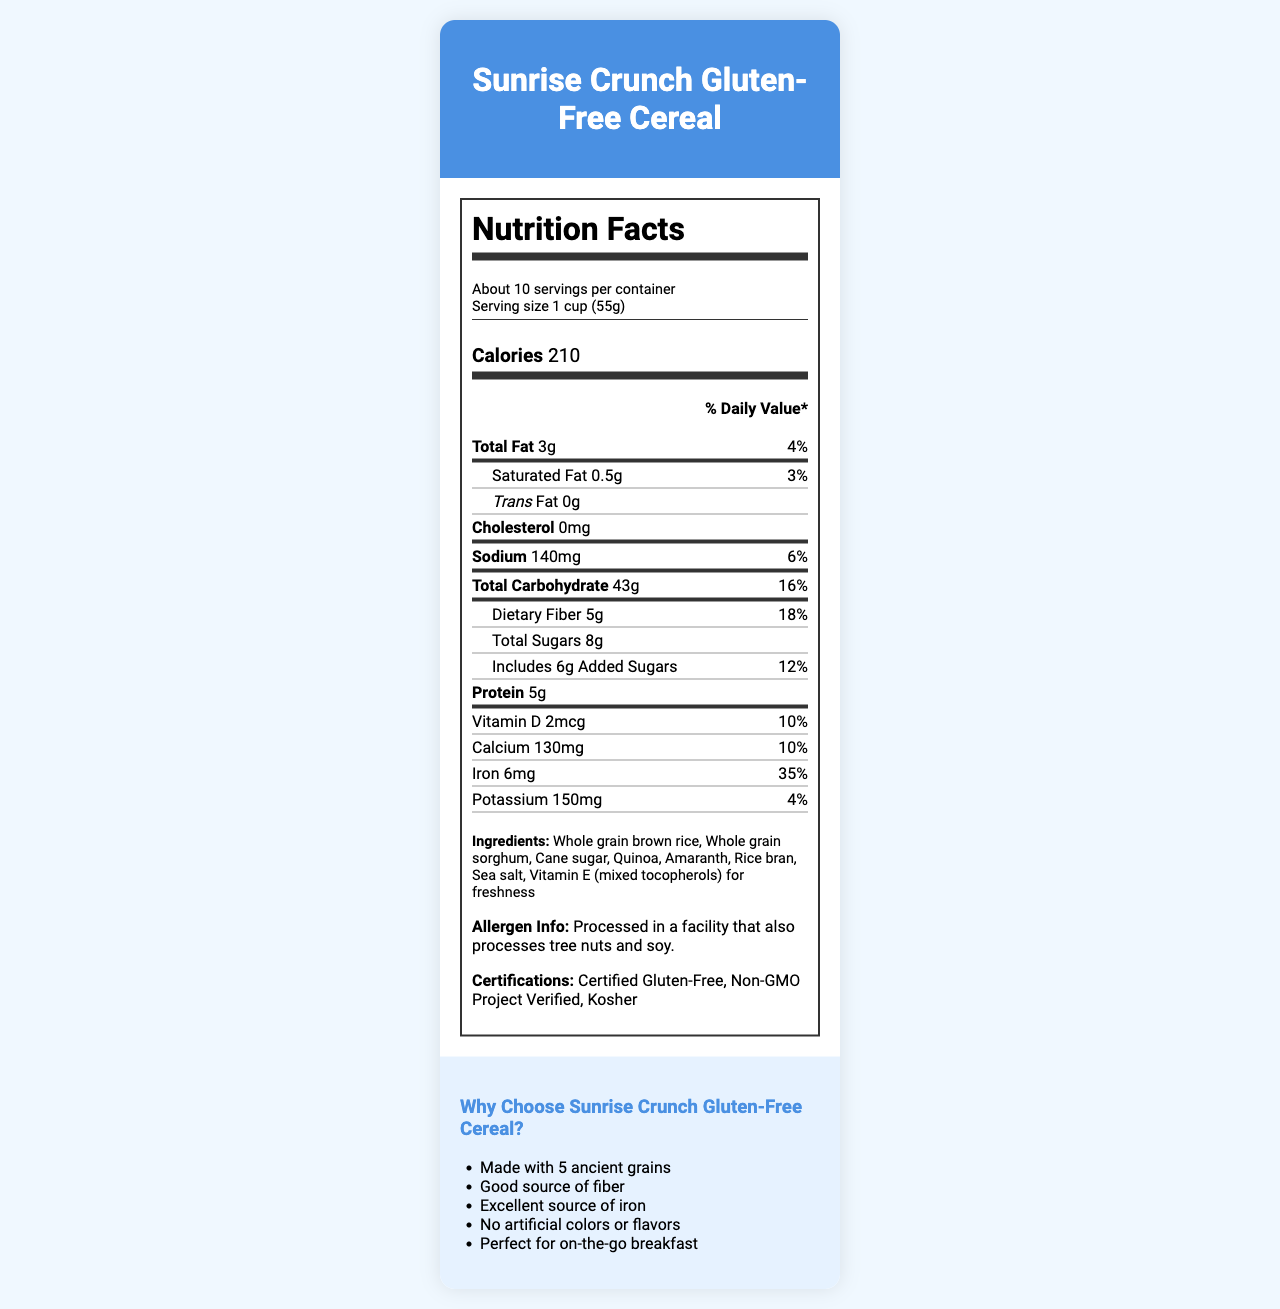what is the serving size for Sunrise Crunch Gluten-Free Cereal? The serving size is explicitly stated in the document as "1 cup (55g)."
Answer: 1 cup (55g) how many servings are there per container? The document mentions that there are "About 10" servings per container.
Answer: About 10 how many calories are in one serving of the cereal? The number of calories per serving is given as 210.
Answer: 210 What are the ingredients in the cereal? The ingredients list in the document includes these items.
Answer: Whole grain brown rice, Whole grain sorghum, Cane sugar, Quinoa, Amaranth, Rice bran, Sea salt, Vitamin E (mixed tocopherols) for freshness what certifications does the product have? The document lists the certifications as "Certified Gluten-Free," "Non-GMO Project Verified," and "Kosher."
Answer: Certified Gluten-Free, Non-GMO Project Verified, Kosher what is the percentage of daily value for iron in one serving? The document notes that the daily value percentage for iron is 35%.
Answer: 35% how much dietary fiber is in one serving? The dietary fiber amount per serving is listed as 5g.
Answer: 5g Which nutrient has the highest daily value percentage in one serving? The Iron content has the highest daily value percentage at 35%.
Answer: Iron what is the amount of sodium in one serving of the cereal? The sodium content per serving is 140mg.
Answer: 140mg what allergen information is provided on the label? The label states the allergen information as "Processed in a facility that also processes tree nuts and soy."
Answer: Processed in a facility that also processes tree nuts and soy. Which of the following points is NOT a marketing highlight mentioned in the document? A. Made with ancient grains B. Certified Organic C. Good source of fiber D. No artificial colors or flavors The document highlights "Made with ancient grains," "Good source of fiber," and "No artificial colors or flavors," but does not mention "Certified Organic."
Answer: B. Certified Organic How much calcium is in one serving of the cereal? A. 150mg B. 120mg C. 130mg D. 140mg The document specifies the calcium content as 130mg.
Answer: C. 130mg is the cereal certified gluten-free? The document states that the cereal is "Certified Gluten-Free."
Answer: Yes Summarize the main points of the document. The document provides important nutritional information, marketing highlights, and a success story featuring the cereal brand's growth.
Answer: The document is a detailed Nutrition Facts Label for "Sunrise Crunch Gluten-Free Cereal" highlighting serving size, calorie content, nutrients, ingredients, allergen info, and certifications. It also includes marketing highlights and success stories from influencer collaboration and small business growth. can the cereal be considered a high source of protein? The document states that one serving has 5g of protein but does not provide criteria to determine if that amount qualifies it as a high source of protein.
Answer: Not enough information 